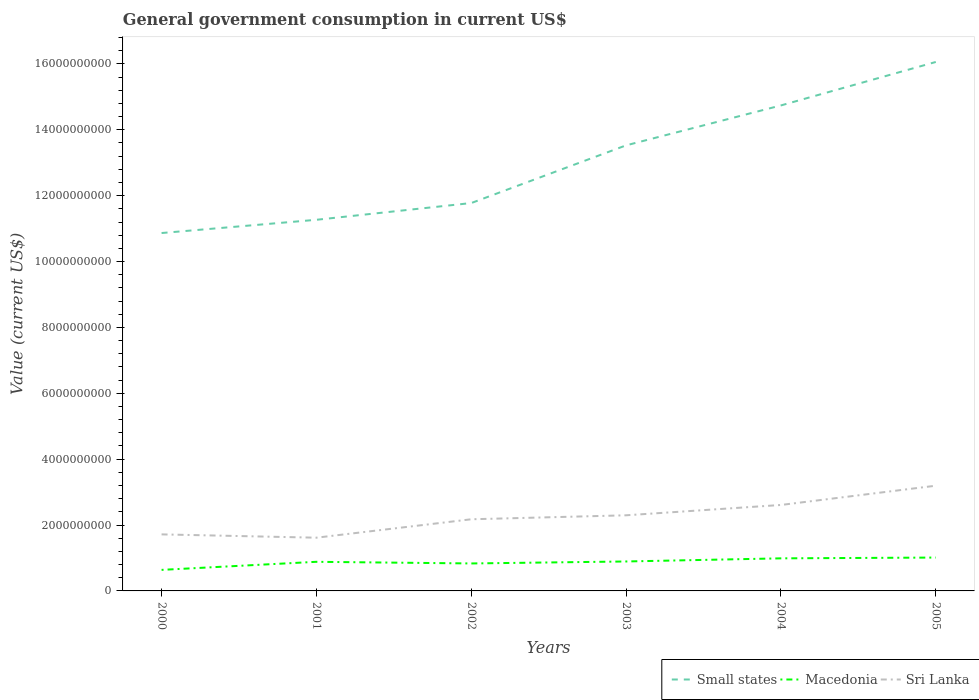Does the line corresponding to Sri Lanka intersect with the line corresponding to Small states?
Your response must be concise. No. Across all years, what is the maximum government conusmption in Small states?
Make the answer very short. 1.09e+1. In which year was the government conusmption in Small states maximum?
Your answer should be very brief. 2000. What is the total government conusmption in Sri Lanka in the graph?
Keep it short and to the point. -6.80e+08. What is the difference between the highest and the second highest government conusmption in Sri Lanka?
Give a very brief answer. 1.58e+09. What is the difference between the highest and the lowest government conusmption in Macedonia?
Provide a succinct answer. 4. Is the government conusmption in Sri Lanka strictly greater than the government conusmption in Macedonia over the years?
Your response must be concise. No. How many lines are there?
Your answer should be very brief. 3. How many years are there in the graph?
Ensure brevity in your answer.  6. What is the difference between two consecutive major ticks on the Y-axis?
Ensure brevity in your answer.  2.00e+09. Are the values on the major ticks of Y-axis written in scientific E-notation?
Keep it short and to the point. No. Does the graph contain any zero values?
Your answer should be very brief. No. Does the graph contain grids?
Your answer should be compact. No. Where does the legend appear in the graph?
Offer a terse response. Bottom right. How many legend labels are there?
Make the answer very short. 3. How are the legend labels stacked?
Provide a succinct answer. Horizontal. What is the title of the graph?
Your response must be concise. General government consumption in current US$. Does "Samoa" appear as one of the legend labels in the graph?
Provide a short and direct response. No. What is the label or title of the X-axis?
Offer a very short reply. Years. What is the label or title of the Y-axis?
Offer a very short reply. Value (current US$). What is the Value (current US$) in Small states in 2000?
Your response must be concise. 1.09e+1. What is the Value (current US$) of Macedonia in 2000?
Make the answer very short. 6.39e+08. What is the Value (current US$) of Sri Lanka in 2000?
Offer a very short reply. 1.72e+09. What is the Value (current US$) of Small states in 2001?
Provide a succinct answer. 1.13e+1. What is the Value (current US$) in Macedonia in 2001?
Give a very brief answer. 8.84e+08. What is the Value (current US$) of Sri Lanka in 2001?
Ensure brevity in your answer.  1.62e+09. What is the Value (current US$) in Small states in 2002?
Your answer should be compact. 1.18e+1. What is the Value (current US$) of Macedonia in 2002?
Make the answer very short. 8.34e+08. What is the Value (current US$) of Sri Lanka in 2002?
Ensure brevity in your answer.  2.18e+09. What is the Value (current US$) in Small states in 2003?
Ensure brevity in your answer.  1.35e+1. What is the Value (current US$) of Macedonia in 2003?
Your answer should be very brief. 8.94e+08. What is the Value (current US$) of Sri Lanka in 2003?
Keep it short and to the point. 2.30e+09. What is the Value (current US$) of Small states in 2004?
Provide a short and direct response. 1.47e+1. What is the Value (current US$) of Macedonia in 2004?
Ensure brevity in your answer.  9.89e+08. What is the Value (current US$) in Sri Lanka in 2004?
Ensure brevity in your answer.  2.61e+09. What is the Value (current US$) of Small states in 2005?
Keep it short and to the point. 1.61e+1. What is the Value (current US$) of Macedonia in 2005?
Your answer should be very brief. 1.01e+09. What is the Value (current US$) in Sri Lanka in 2005?
Offer a terse response. 3.19e+09. Across all years, what is the maximum Value (current US$) of Small states?
Ensure brevity in your answer.  1.61e+1. Across all years, what is the maximum Value (current US$) of Macedonia?
Make the answer very short. 1.01e+09. Across all years, what is the maximum Value (current US$) in Sri Lanka?
Offer a terse response. 3.19e+09. Across all years, what is the minimum Value (current US$) of Small states?
Offer a terse response. 1.09e+1. Across all years, what is the minimum Value (current US$) in Macedonia?
Your response must be concise. 6.39e+08. Across all years, what is the minimum Value (current US$) in Sri Lanka?
Give a very brief answer. 1.62e+09. What is the total Value (current US$) in Small states in the graph?
Offer a terse response. 7.82e+1. What is the total Value (current US$) of Macedonia in the graph?
Your answer should be compact. 5.25e+09. What is the total Value (current US$) in Sri Lanka in the graph?
Give a very brief answer. 1.36e+1. What is the difference between the Value (current US$) in Small states in 2000 and that in 2001?
Provide a succinct answer. -4.02e+08. What is the difference between the Value (current US$) of Macedonia in 2000 and that in 2001?
Provide a succinct answer. -2.45e+08. What is the difference between the Value (current US$) of Sri Lanka in 2000 and that in 2001?
Ensure brevity in your answer.  1.00e+08. What is the difference between the Value (current US$) in Small states in 2000 and that in 2002?
Your answer should be compact. -9.11e+08. What is the difference between the Value (current US$) in Macedonia in 2000 and that in 2002?
Give a very brief answer. -1.95e+08. What is the difference between the Value (current US$) of Sri Lanka in 2000 and that in 2002?
Keep it short and to the point. -4.59e+08. What is the difference between the Value (current US$) of Small states in 2000 and that in 2003?
Provide a succinct answer. -2.66e+09. What is the difference between the Value (current US$) in Macedonia in 2000 and that in 2003?
Your response must be concise. -2.55e+08. What is the difference between the Value (current US$) in Sri Lanka in 2000 and that in 2003?
Ensure brevity in your answer.  -5.80e+08. What is the difference between the Value (current US$) in Small states in 2000 and that in 2004?
Give a very brief answer. -3.87e+09. What is the difference between the Value (current US$) in Macedonia in 2000 and that in 2004?
Your answer should be very brief. -3.50e+08. What is the difference between the Value (current US$) of Sri Lanka in 2000 and that in 2004?
Give a very brief answer. -8.93e+08. What is the difference between the Value (current US$) of Small states in 2000 and that in 2005?
Offer a very short reply. -5.19e+09. What is the difference between the Value (current US$) of Macedonia in 2000 and that in 2005?
Give a very brief answer. -3.74e+08. What is the difference between the Value (current US$) in Sri Lanka in 2000 and that in 2005?
Keep it short and to the point. -1.48e+09. What is the difference between the Value (current US$) of Small states in 2001 and that in 2002?
Give a very brief answer. -5.09e+08. What is the difference between the Value (current US$) of Macedonia in 2001 and that in 2002?
Provide a succinct answer. 5.02e+07. What is the difference between the Value (current US$) of Sri Lanka in 2001 and that in 2002?
Provide a succinct answer. -5.59e+08. What is the difference between the Value (current US$) of Small states in 2001 and that in 2003?
Keep it short and to the point. -2.26e+09. What is the difference between the Value (current US$) in Macedonia in 2001 and that in 2003?
Provide a succinct answer. -1.02e+07. What is the difference between the Value (current US$) in Sri Lanka in 2001 and that in 2003?
Give a very brief answer. -6.80e+08. What is the difference between the Value (current US$) in Small states in 2001 and that in 2004?
Ensure brevity in your answer.  -3.47e+09. What is the difference between the Value (current US$) of Macedonia in 2001 and that in 2004?
Offer a terse response. -1.05e+08. What is the difference between the Value (current US$) of Sri Lanka in 2001 and that in 2004?
Keep it short and to the point. -9.94e+08. What is the difference between the Value (current US$) in Small states in 2001 and that in 2005?
Your response must be concise. -4.79e+09. What is the difference between the Value (current US$) of Macedonia in 2001 and that in 2005?
Your answer should be very brief. -1.29e+08. What is the difference between the Value (current US$) in Sri Lanka in 2001 and that in 2005?
Give a very brief answer. -1.58e+09. What is the difference between the Value (current US$) in Small states in 2002 and that in 2003?
Ensure brevity in your answer.  -1.75e+09. What is the difference between the Value (current US$) of Macedonia in 2002 and that in 2003?
Give a very brief answer. -6.04e+07. What is the difference between the Value (current US$) in Sri Lanka in 2002 and that in 2003?
Provide a succinct answer. -1.21e+08. What is the difference between the Value (current US$) of Small states in 2002 and that in 2004?
Your answer should be compact. -2.96e+09. What is the difference between the Value (current US$) of Macedonia in 2002 and that in 2004?
Give a very brief answer. -1.55e+08. What is the difference between the Value (current US$) in Sri Lanka in 2002 and that in 2004?
Provide a succinct answer. -4.34e+08. What is the difference between the Value (current US$) of Small states in 2002 and that in 2005?
Your answer should be very brief. -4.28e+09. What is the difference between the Value (current US$) in Macedonia in 2002 and that in 2005?
Your answer should be very brief. -1.79e+08. What is the difference between the Value (current US$) of Sri Lanka in 2002 and that in 2005?
Offer a very short reply. -1.02e+09. What is the difference between the Value (current US$) of Small states in 2003 and that in 2004?
Offer a terse response. -1.21e+09. What is the difference between the Value (current US$) of Macedonia in 2003 and that in 2004?
Your answer should be compact. -9.48e+07. What is the difference between the Value (current US$) in Sri Lanka in 2003 and that in 2004?
Give a very brief answer. -3.14e+08. What is the difference between the Value (current US$) of Small states in 2003 and that in 2005?
Provide a short and direct response. -2.53e+09. What is the difference between the Value (current US$) in Macedonia in 2003 and that in 2005?
Offer a very short reply. -1.19e+08. What is the difference between the Value (current US$) in Sri Lanka in 2003 and that in 2005?
Offer a terse response. -8.98e+08. What is the difference between the Value (current US$) of Small states in 2004 and that in 2005?
Provide a succinct answer. -1.32e+09. What is the difference between the Value (current US$) in Macedonia in 2004 and that in 2005?
Offer a terse response. -2.39e+07. What is the difference between the Value (current US$) in Sri Lanka in 2004 and that in 2005?
Provide a succinct answer. -5.85e+08. What is the difference between the Value (current US$) in Small states in 2000 and the Value (current US$) in Macedonia in 2001?
Ensure brevity in your answer.  9.98e+09. What is the difference between the Value (current US$) of Small states in 2000 and the Value (current US$) of Sri Lanka in 2001?
Give a very brief answer. 9.25e+09. What is the difference between the Value (current US$) in Macedonia in 2000 and the Value (current US$) in Sri Lanka in 2001?
Provide a short and direct response. -9.77e+08. What is the difference between the Value (current US$) of Small states in 2000 and the Value (current US$) of Macedonia in 2002?
Your answer should be compact. 1.00e+1. What is the difference between the Value (current US$) in Small states in 2000 and the Value (current US$) in Sri Lanka in 2002?
Provide a short and direct response. 8.69e+09. What is the difference between the Value (current US$) in Macedonia in 2000 and the Value (current US$) in Sri Lanka in 2002?
Provide a short and direct response. -1.54e+09. What is the difference between the Value (current US$) in Small states in 2000 and the Value (current US$) in Macedonia in 2003?
Offer a very short reply. 9.97e+09. What is the difference between the Value (current US$) of Small states in 2000 and the Value (current US$) of Sri Lanka in 2003?
Provide a succinct answer. 8.57e+09. What is the difference between the Value (current US$) in Macedonia in 2000 and the Value (current US$) in Sri Lanka in 2003?
Your response must be concise. -1.66e+09. What is the difference between the Value (current US$) of Small states in 2000 and the Value (current US$) of Macedonia in 2004?
Provide a succinct answer. 9.88e+09. What is the difference between the Value (current US$) of Small states in 2000 and the Value (current US$) of Sri Lanka in 2004?
Your answer should be very brief. 8.26e+09. What is the difference between the Value (current US$) of Macedonia in 2000 and the Value (current US$) of Sri Lanka in 2004?
Your answer should be very brief. -1.97e+09. What is the difference between the Value (current US$) in Small states in 2000 and the Value (current US$) in Macedonia in 2005?
Keep it short and to the point. 9.85e+09. What is the difference between the Value (current US$) in Small states in 2000 and the Value (current US$) in Sri Lanka in 2005?
Your answer should be compact. 7.67e+09. What is the difference between the Value (current US$) in Macedonia in 2000 and the Value (current US$) in Sri Lanka in 2005?
Offer a very short reply. -2.56e+09. What is the difference between the Value (current US$) in Small states in 2001 and the Value (current US$) in Macedonia in 2002?
Give a very brief answer. 1.04e+1. What is the difference between the Value (current US$) of Small states in 2001 and the Value (current US$) of Sri Lanka in 2002?
Your response must be concise. 9.09e+09. What is the difference between the Value (current US$) in Macedonia in 2001 and the Value (current US$) in Sri Lanka in 2002?
Your answer should be very brief. -1.29e+09. What is the difference between the Value (current US$) of Small states in 2001 and the Value (current US$) of Macedonia in 2003?
Make the answer very short. 1.04e+1. What is the difference between the Value (current US$) in Small states in 2001 and the Value (current US$) in Sri Lanka in 2003?
Offer a very short reply. 8.97e+09. What is the difference between the Value (current US$) in Macedonia in 2001 and the Value (current US$) in Sri Lanka in 2003?
Ensure brevity in your answer.  -1.41e+09. What is the difference between the Value (current US$) in Small states in 2001 and the Value (current US$) in Macedonia in 2004?
Offer a terse response. 1.03e+1. What is the difference between the Value (current US$) in Small states in 2001 and the Value (current US$) in Sri Lanka in 2004?
Your response must be concise. 8.66e+09. What is the difference between the Value (current US$) in Macedonia in 2001 and the Value (current US$) in Sri Lanka in 2004?
Give a very brief answer. -1.73e+09. What is the difference between the Value (current US$) of Small states in 2001 and the Value (current US$) of Macedonia in 2005?
Your response must be concise. 1.03e+1. What is the difference between the Value (current US$) in Small states in 2001 and the Value (current US$) in Sri Lanka in 2005?
Give a very brief answer. 8.07e+09. What is the difference between the Value (current US$) in Macedonia in 2001 and the Value (current US$) in Sri Lanka in 2005?
Your answer should be very brief. -2.31e+09. What is the difference between the Value (current US$) in Small states in 2002 and the Value (current US$) in Macedonia in 2003?
Provide a short and direct response. 1.09e+1. What is the difference between the Value (current US$) of Small states in 2002 and the Value (current US$) of Sri Lanka in 2003?
Your response must be concise. 9.48e+09. What is the difference between the Value (current US$) of Macedonia in 2002 and the Value (current US$) of Sri Lanka in 2003?
Provide a short and direct response. -1.46e+09. What is the difference between the Value (current US$) in Small states in 2002 and the Value (current US$) in Macedonia in 2004?
Ensure brevity in your answer.  1.08e+1. What is the difference between the Value (current US$) in Small states in 2002 and the Value (current US$) in Sri Lanka in 2004?
Offer a very short reply. 9.17e+09. What is the difference between the Value (current US$) of Macedonia in 2002 and the Value (current US$) of Sri Lanka in 2004?
Offer a terse response. -1.78e+09. What is the difference between the Value (current US$) in Small states in 2002 and the Value (current US$) in Macedonia in 2005?
Keep it short and to the point. 1.08e+1. What is the difference between the Value (current US$) in Small states in 2002 and the Value (current US$) in Sri Lanka in 2005?
Offer a terse response. 8.58e+09. What is the difference between the Value (current US$) of Macedonia in 2002 and the Value (current US$) of Sri Lanka in 2005?
Keep it short and to the point. -2.36e+09. What is the difference between the Value (current US$) of Small states in 2003 and the Value (current US$) of Macedonia in 2004?
Ensure brevity in your answer.  1.25e+1. What is the difference between the Value (current US$) of Small states in 2003 and the Value (current US$) of Sri Lanka in 2004?
Offer a terse response. 1.09e+1. What is the difference between the Value (current US$) in Macedonia in 2003 and the Value (current US$) in Sri Lanka in 2004?
Your answer should be compact. -1.72e+09. What is the difference between the Value (current US$) in Small states in 2003 and the Value (current US$) in Macedonia in 2005?
Your answer should be very brief. 1.25e+1. What is the difference between the Value (current US$) of Small states in 2003 and the Value (current US$) of Sri Lanka in 2005?
Provide a short and direct response. 1.03e+1. What is the difference between the Value (current US$) of Macedonia in 2003 and the Value (current US$) of Sri Lanka in 2005?
Your answer should be compact. -2.30e+09. What is the difference between the Value (current US$) in Small states in 2004 and the Value (current US$) in Macedonia in 2005?
Your answer should be very brief. 1.37e+1. What is the difference between the Value (current US$) of Small states in 2004 and the Value (current US$) of Sri Lanka in 2005?
Your answer should be very brief. 1.15e+1. What is the difference between the Value (current US$) of Macedonia in 2004 and the Value (current US$) of Sri Lanka in 2005?
Keep it short and to the point. -2.21e+09. What is the average Value (current US$) in Small states per year?
Make the answer very short. 1.30e+1. What is the average Value (current US$) of Macedonia per year?
Your response must be concise. 8.76e+08. What is the average Value (current US$) in Sri Lanka per year?
Provide a short and direct response. 2.27e+09. In the year 2000, what is the difference between the Value (current US$) in Small states and Value (current US$) in Macedonia?
Your response must be concise. 1.02e+1. In the year 2000, what is the difference between the Value (current US$) in Small states and Value (current US$) in Sri Lanka?
Provide a short and direct response. 9.15e+09. In the year 2000, what is the difference between the Value (current US$) in Macedonia and Value (current US$) in Sri Lanka?
Provide a succinct answer. -1.08e+09. In the year 2001, what is the difference between the Value (current US$) in Small states and Value (current US$) in Macedonia?
Your response must be concise. 1.04e+1. In the year 2001, what is the difference between the Value (current US$) of Small states and Value (current US$) of Sri Lanka?
Provide a succinct answer. 9.65e+09. In the year 2001, what is the difference between the Value (current US$) in Macedonia and Value (current US$) in Sri Lanka?
Keep it short and to the point. -7.32e+08. In the year 2002, what is the difference between the Value (current US$) of Small states and Value (current US$) of Macedonia?
Offer a terse response. 1.09e+1. In the year 2002, what is the difference between the Value (current US$) in Small states and Value (current US$) in Sri Lanka?
Provide a short and direct response. 9.60e+09. In the year 2002, what is the difference between the Value (current US$) in Macedonia and Value (current US$) in Sri Lanka?
Ensure brevity in your answer.  -1.34e+09. In the year 2003, what is the difference between the Value (current US$) in Small states and Value (current US$) in Macedonia?
Provide a short and direct response. 1.26e+1. In the year 2003, what is the difference between the Value (current US$) of Small states and Value (current US$) of Sri Lanka?
Offer a terse response. 1.12e+1. In the year 2003, what is the difference between the Value (current US$) in Macedonia and Value (current US$) in Sri Lanka?
Give a very brief answer. -1.40e+09. In the year 2004, what is the difference between the Value (current US$) in Small states and Value (current US$) in Macedonia?
Ensure brevity in your answer.  1.38e+1. In the year 2004, what is the difference between the Value (current US$) in Small states and Value (current US$) in Sri Lanka?
Offer a very short reply. 1.21e+1. In the year 2004, what is the difference between the Value (current US$) in Macedonia and Value (current US$) in Sri Lanka?
Ensure brevity in your answer.  -1.62e+09. In the year 2005, what is the difference between the Value (current US$) of Small states and Value (current US$) of Macedonia?
Give a very brief answer. 1.50e+1. In the year 2005, what is the difference between the Value (current US$) of Small states and Value (current US$) of Sri Lanka?
Your answer should be compact. 1.29e+1. In the year 2005, what is the difference between the Value (current US$) of Macedonia and Value (current US$) of Sri Lanka?
Your answer should be compact. -2.18e+09. What is the ratio of the Value (current US$) of Macedonia in 2000 to that in 2001?
Give a very brief answer. 0.72. What is the ratio of the Value (current US$) in Sri Lanka in 2000 to that in 2001?
Provide a short and direct response. 1.06. What is the ratio of the Value (current US$) in Small states in 2000 to that in 2002?
Offer a terse response. 0.92. What is the ratio of the Value (current US$) of Macedonia in 2000 to that in 2002?
Keep it short and to the point. 0.77. What is the ratio of the Value (current US$) in Sri Lanka in 2000 to that in 2002?
Offer a terse response. 0.79. What is the ratio of the Value (current US$) in Small states in 2000 to that in 2003?
Make the answer very short. 0.8. What is the ratio of the Value (current US$) in Sri Lanka in 2000 to that in 2003?
Your answer should be compact. 0.75. What is the ratio of the Value (current US$) of Small states in 2000 to that in 2004?
Ensure brevity in your answer.  0.74. What is the ratio of the Value (current US$) of Macedonia in 2000 to that in 2004?
Provide a short and direct response. 0.65. What is the ratio of the Value (current US$) of Sri Lanka in 2000 to that in 2004?
Your response must be concise. 0.66. What is the ratio of the Value (current US$) of Small states in 2000 to that in 2005?
Provide a succinct answer. 0.68. What is the ratio of the Value (current US$) in Macedonia in 2000 to that in 2005?
Give a very brief answer. 0.63. What is the ratio of the Value (current US$) in Sri Lanka in 2000 to that in 2005?
Your response must be concise. 0.54. What is the ratio of the Value (current US$) in Small states in 2001 to that in 2002?
Ensure brevity in your answer.  0.96. What is the ratio of the Value (current US$) of Macedonia in 2001 to that in 2002?
Provide a short and direct response. 1.06. What is the ratio of the Value (current US$) in Sri Lanka in 2001 to that in 2002?
Make the answer very short. 0.74. What is the ratio of the Value (current US$) of Small states in 2001 to that in 2003?
Give a very brief answer. 0.83. What is the ratio of the Value (current US$) in Sri Lanka in 2001 to that in 2003?
Provide a short and direct response. 0.7. What is the ratio of the Value (current US$) in Small states in 2001 to that in 2004?
Keep it short and to the point. 0.76. What is the ratio of the Value (current US$) in Macedonia in 2001 to that in 2004?
Your answer should be compact. 0.89. What is the ratio of the Value (current US$) of Sri Lanka in 2001 to that in 2004?
Give a very brief answer. 0.62. What is the ratio of the Value (current US$) of Small states in 2001 to that in 2005?
Your answer should be very brief. 0.7. What is the ratio of the Value (current US$) of Macedonia in 2001 to that in 2005?
Your response must be concise. 0.87. What is the ratio of the Value (current US$) in Sri Lanka in 2001 to that in 2005?
Make the answer very short. 0.51. What is the ratio of the Value (current US$) of Small states in 2002 to that in 2003?
Your response must be concise. 0.87. What is the ratio of the Value (current US$) in Macedonia in 2002 to that in 2003?
Provide a short and direct response. 0.93. What is the ratio of the Value (current US$) of Small states in 2002 to that in 2004?
Provide a succinct answer. 0.8. What is the ratio of the Value (current US$) in Macedonia in 2002 to that in 2004?
Ensure brevity in your answer.  0.84. What is the ratio of the Value (current US$) in Sri Lanka in 2002 to that in 2004?
Keep it short and to the point. 0.83. What is the ratio of the Value (current US$) of Small states in 2002 to that in 2005?
Offer a very short reply. 0.73. What is the ratio of the Value (current US$) of Macedonia in 2002 to that in 2005?
Offer a terse response. 0.82. What is the ratio of the Value (current US$) in Sri Lanka in 2002 to that in 2005?
Give a very brief answer. 0.68. What is the ratio of the Value (current US$) in Small states in 2003 to that in 2004?
Offer a very short reply. 0.92. What is the ratio of the Value (current US$) of Macedonia in 2003 to that in 2004?
Provide a succinct answer. 0.9. What is the ratio of the Value (current US$) of Sri Lanka in 2003 to that in 2004?
Offer a very short reply. 0.88. What is the ratio of the Value (current US$) of Small states in 2003 to that in 2005?
Ensure brevity in your answer.  0.84. What is the ratio of the Value (current US$) of Macedonia in 2003 to that in 2005?
Provide a succinct answer. 0.88. What is the ratio of the Value (current US$) of Sri Lanka in 2003 to that in 2005?
Give a very brief answer. 0.72. What is the ratio of the Value (current US$) in Small states in 2004 to that in 2005?
Your answer should be very brief. 0.92. What is the ratio of the Value (current US$) in Macedonia in 2004 to that in 2005?
Provide a succinct answer. 0.98. What is the ratio of the Value (current US$) in Sri Lanka in 2004 to that in 2005?
Offer a very short reply. 0.82. What is the difference between the highest and the second highest Value (current US$) of Small states?
Ensure brevity in your answer.  1.32e+09. What is the difference between the highest and the second highest Value (current US$) in Macedonia?
Make the answer very short. 2.39e+07. What is the difference between the highest and the second highest Value (current US$) in Sri Lanka?
Offer a very short reply. 5.85e+08. What is the difference between the highest and the lowest Value (current US$) of Small states?
Make the answer very short. 5.19e+09. What is the difference between the highest and the lowest Value (current US$) of Macedonia?
Ensure brevity in your answer.  3.74e+08. What is the difference between the highest and the lowest Value (current US$) in Sri Lanka?
Offer a very short reply. 1.58e+09. 